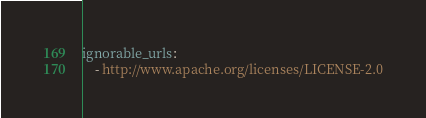Convert code to text. <code><loc_0><loc_0><loc_500><loc_500><_YAML_>ignorable_urls:
    - http://www.apache.org/licenses/LICENSE-2.0
</code> 